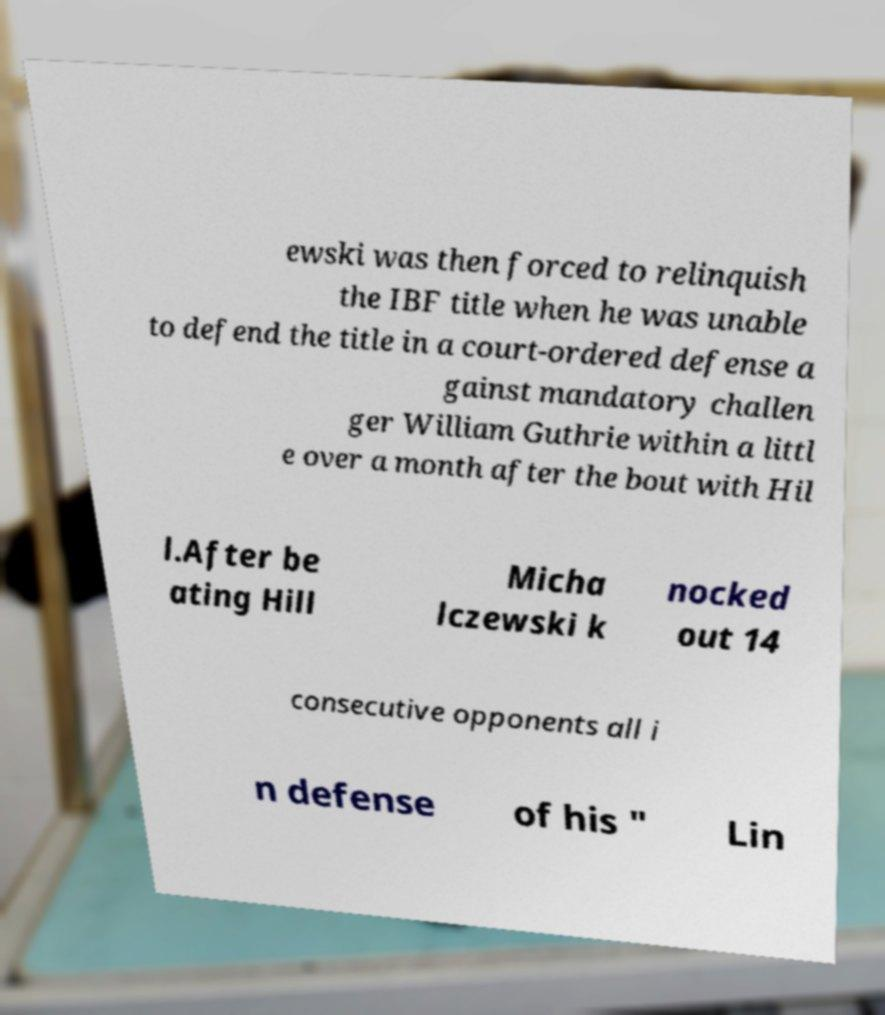What messages or text are displayed in this image? I need them in a readable, typed format. ewski was then forced to relinquish the IBF title when he was unable to defend the title in a court-ordered defense a gainst mandatory challen ger William Guthrie within a littl e over a month after the bout with Hil l.After be ating Hill Micha lczewski k nocked out 14 consecutive opponents all i n defense of his " Lin 